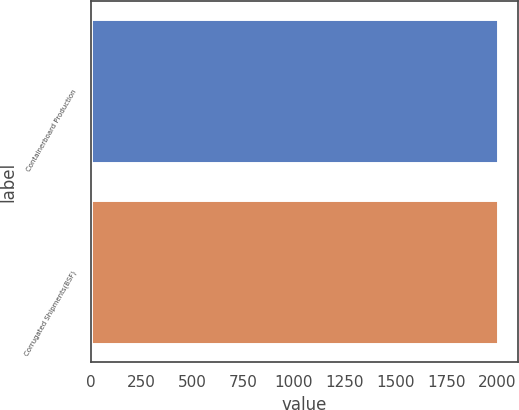Convert chart to OTSL. <chart><loc_0><loc_0><loc_500><loc_500><bar_chart><fcel>Containerboard Production<fcel>Corrugated Shipments(BSF)<nl><fcel>2004<fcel>2004.1<nl></chart> 